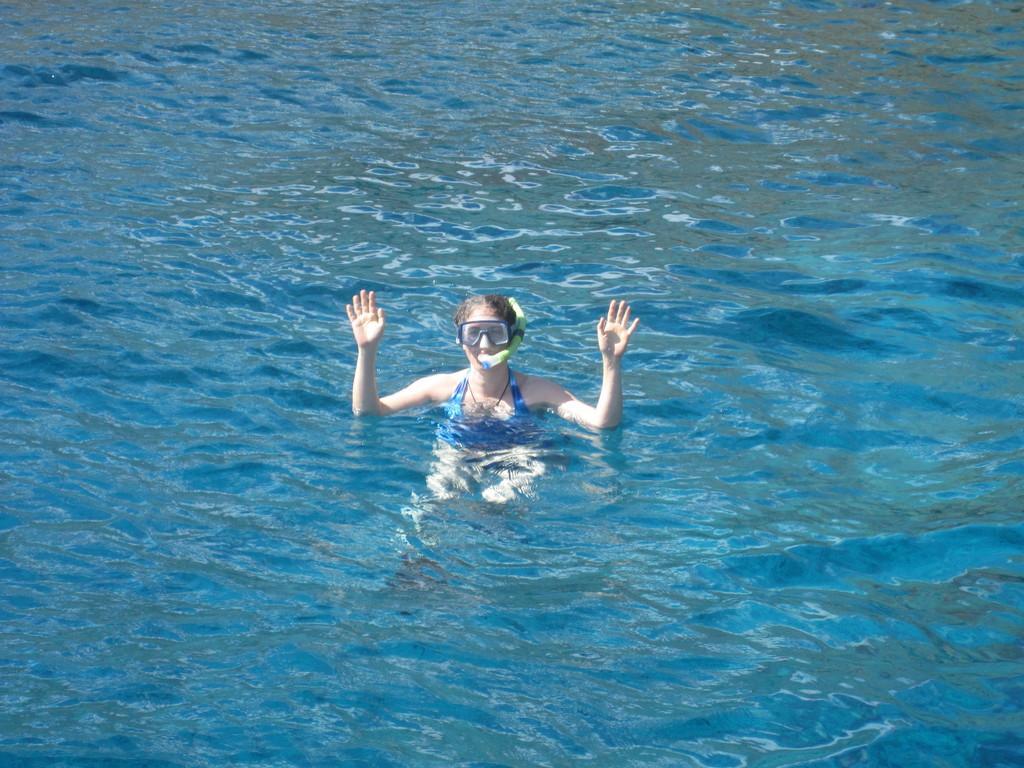Describe this image in one or two sentences. In this image, in the middle, we can see a woman drowning on the water. In the background, we can see a water. 